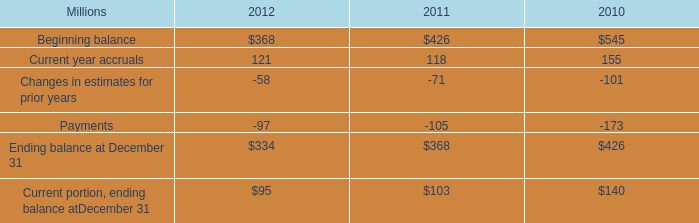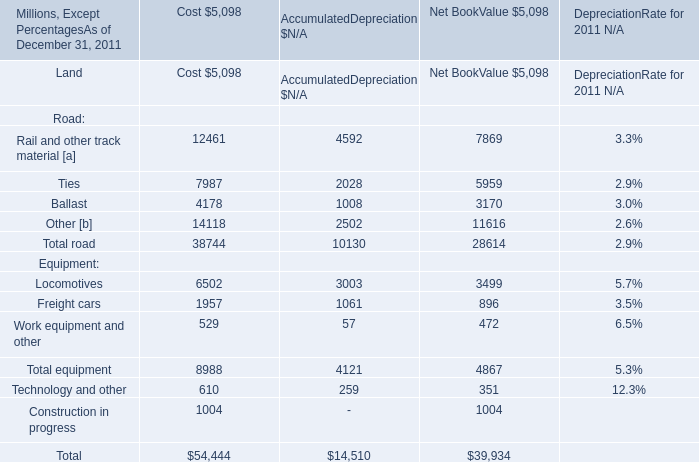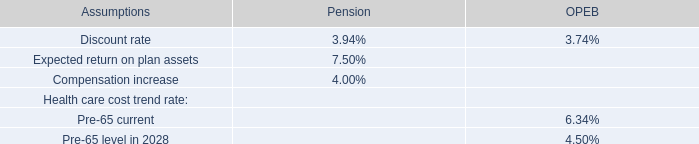What's the 20 % of total road in 2011 for net book value? (in million) 
Computations: (28614 * 0.2)
Answer: 5722.8. 